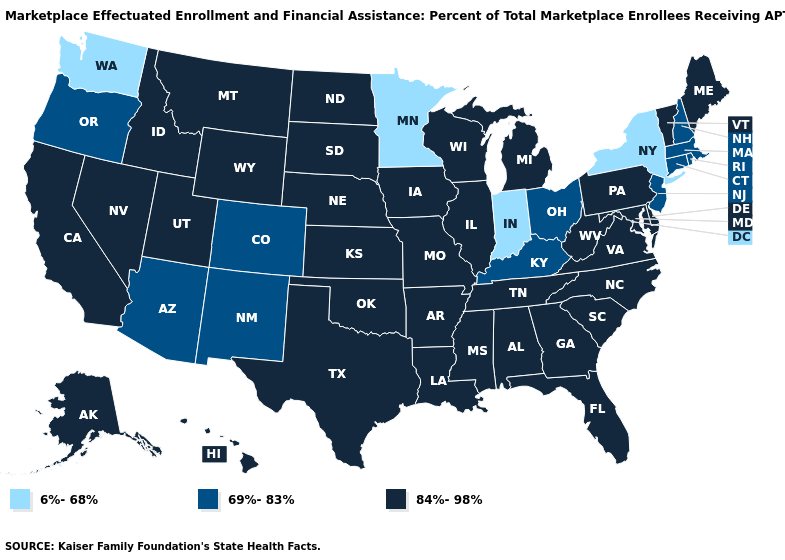Name the states that have a value in the range 6%-68%?
Answer briefly. Indiana, Minnesota, New York, Washington. What is the value of North Carolina?
Quick response, please. 84%-98%. Name the states that have a value in the range 69%-83%?
Concise answer only. Arizona, Colorado, Connecticut, Kentucky, Massachusetts, New Hampshire, New Jersey, New Mexico, Ohio, Oregon, Rhode Island. What is the value of Connecticut?
Give a very brief answer. 69%-83%. Name the states that have a value in the range 84%-98%?
Give a very brief answer. Alabama, Alaska, Arkansas, California, Delaware, Florida, Georgia, Hawaii, Idaho, Illinois, Iowa, Kansas, Louisiana, Maine, Maryland, Michigan, Mississippi, Missouri, Montana, Nebraska, Nevada, North Carolina, North Dakota, Oklahoma, Pennsylvania, South Carolina, South Dakota, Tennessee, Texas, Utah, Vermont, Virginia, West Virginia, Wisconsin, Wyoming. What is the value of Alabama?
Keep it brief. 84%-98%. Does the first symbol in the legend represent the smallest category?
Give a very brief answer. Yes. What is the highest value in states that border Idaho?
Give a very brief answer. 84%-98%. What is the value of Virginia?
Quick response, please. 84%-98%. What is the highest value in the USA?
Be succinct. 84%-98%. Is the legend a continuous bar?
Give a very brief answer. No. Does Rhode Island have a lower value than New Jersey?
Write a very short answer. No. Does Massachusetts have the highest value in the Northeast?
Concise answer only. No. Which states have the highest value in the USA?
Keep it brief. Alabama, Alaska, Arkansas, California, Delaware, Florida, Georgia, Hawaii, Idaho, Illinois, Iowa, Kansas, Louisiana, Maine, Maryland, Michigan, Mississippi, Missouri, Montana, Nebraska, Nevada, North Carolina, North Dakota, Oklahoma, Pennsylvania, South Carolina, South Dakota, Tennessee, Texas, Utah, Vermont, Virginia, West Virginia, Wisconsin, Wyoming. What is the value of Illinois?
Concise answer only. 84%-98%. 